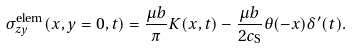<formula> <loc_0><loc_0><loc_500><loc_500>\sigma ^ { \text {elem} } _ { z y } ( x , y = 0 , t ) = \frac { \mu b } { \pi } K ( x , t ) - \frac { \mu b } { 2 c _ { \text {S} } } \theta ( - x ) \delta ^ { \prime } ( t ) .</formula> 